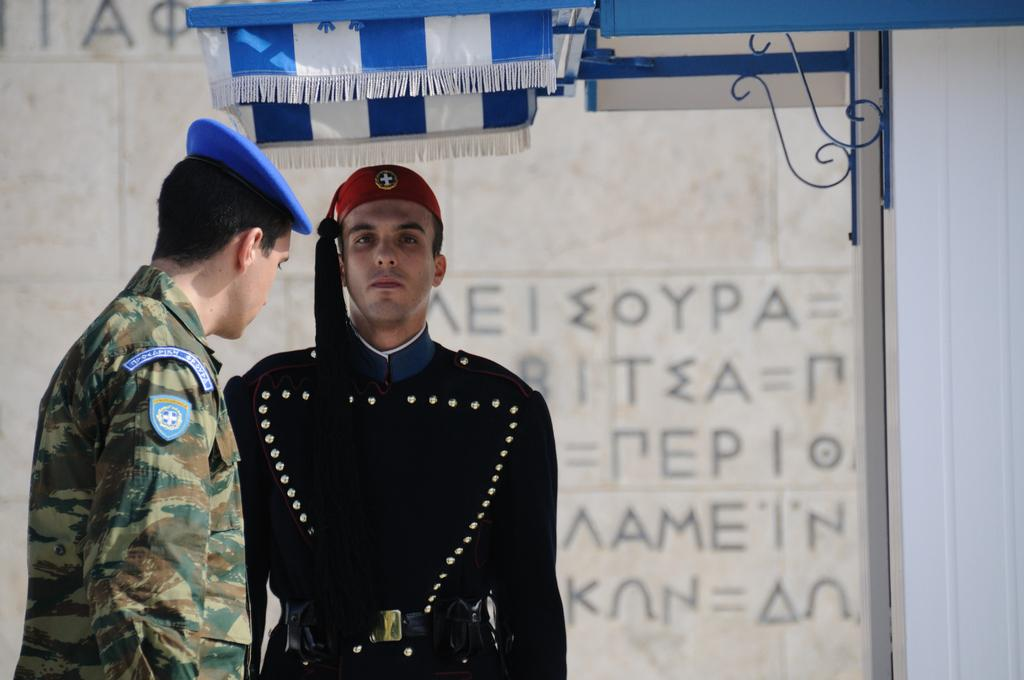What can be seen in the foreground of the image? There are persons standing in the front of the image. What structure is visible in the background of the image? There is a tent in the background of the image. What is the color of the tent? The tent is blue in color. What is written on the wall in the background of the image? There is text written on the wall in the background. Can you tell me how much rice is stored in the tent in the image? There is no mention of rice or a store in the image; it features a blue tent and persons standing in the front. 